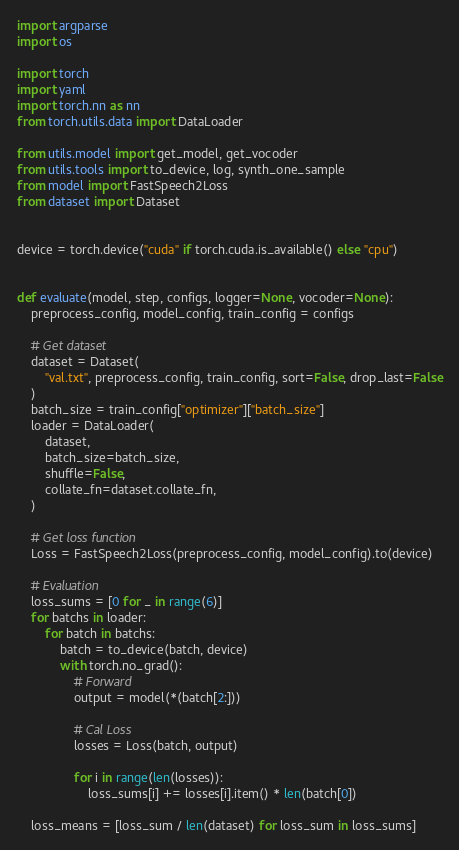<code> <loc_0><loc_0><loc_500><loc_500><_Python_>import argparse
import os

import torch
import yaml
import torch.nn as nn
from torch.utils.data import DataLoader

from utils.model import get_model, get_vocoder
from utils.tools import to_device, log, synth_one_sample
from model import FastSpeech2Loss
from dataset import Dataset


device = torch.device("cuda" if torch.cuda.is_available() else "cpu")


def evaluate(model, step, configs, logger=None, vocoder=None):
    preprocess_config, model_config, train_config = configs

    # Get dataset
    dataset = Dataset(
        "val.txt", preprocess_config, train_config, sort=False, drop_last=False
    )
    batch_size = train_config["optimizer"]["batch_size"]
    loader = DataLoader(
        dataset,
        batch_size=batch_size,
        shuffle=False,
        collate_fn=dataset.collate_fn,
    )

    # Get loss function
    Loss = FastSpeech2Loss(preprocess_config, model_config).to(device)

    # Evaluation
    loss_sums = [0 for _ in range(6)]
    for batchs in loader:
        for batch in batchs:
            batch = to_device(batch, device)
            with torch.no_grad():
                # Forward
                output = model(*(batch[2:]))

                # Cal Loss
                losses = Loss(batch, output)

                for i in range(len(losses)):
                    loss_sums[i] += losses[i].item() * len(batch[0])

    loss_means = [loss_sum / len(dataset) for loss_sum in loss_sums]
</code> 